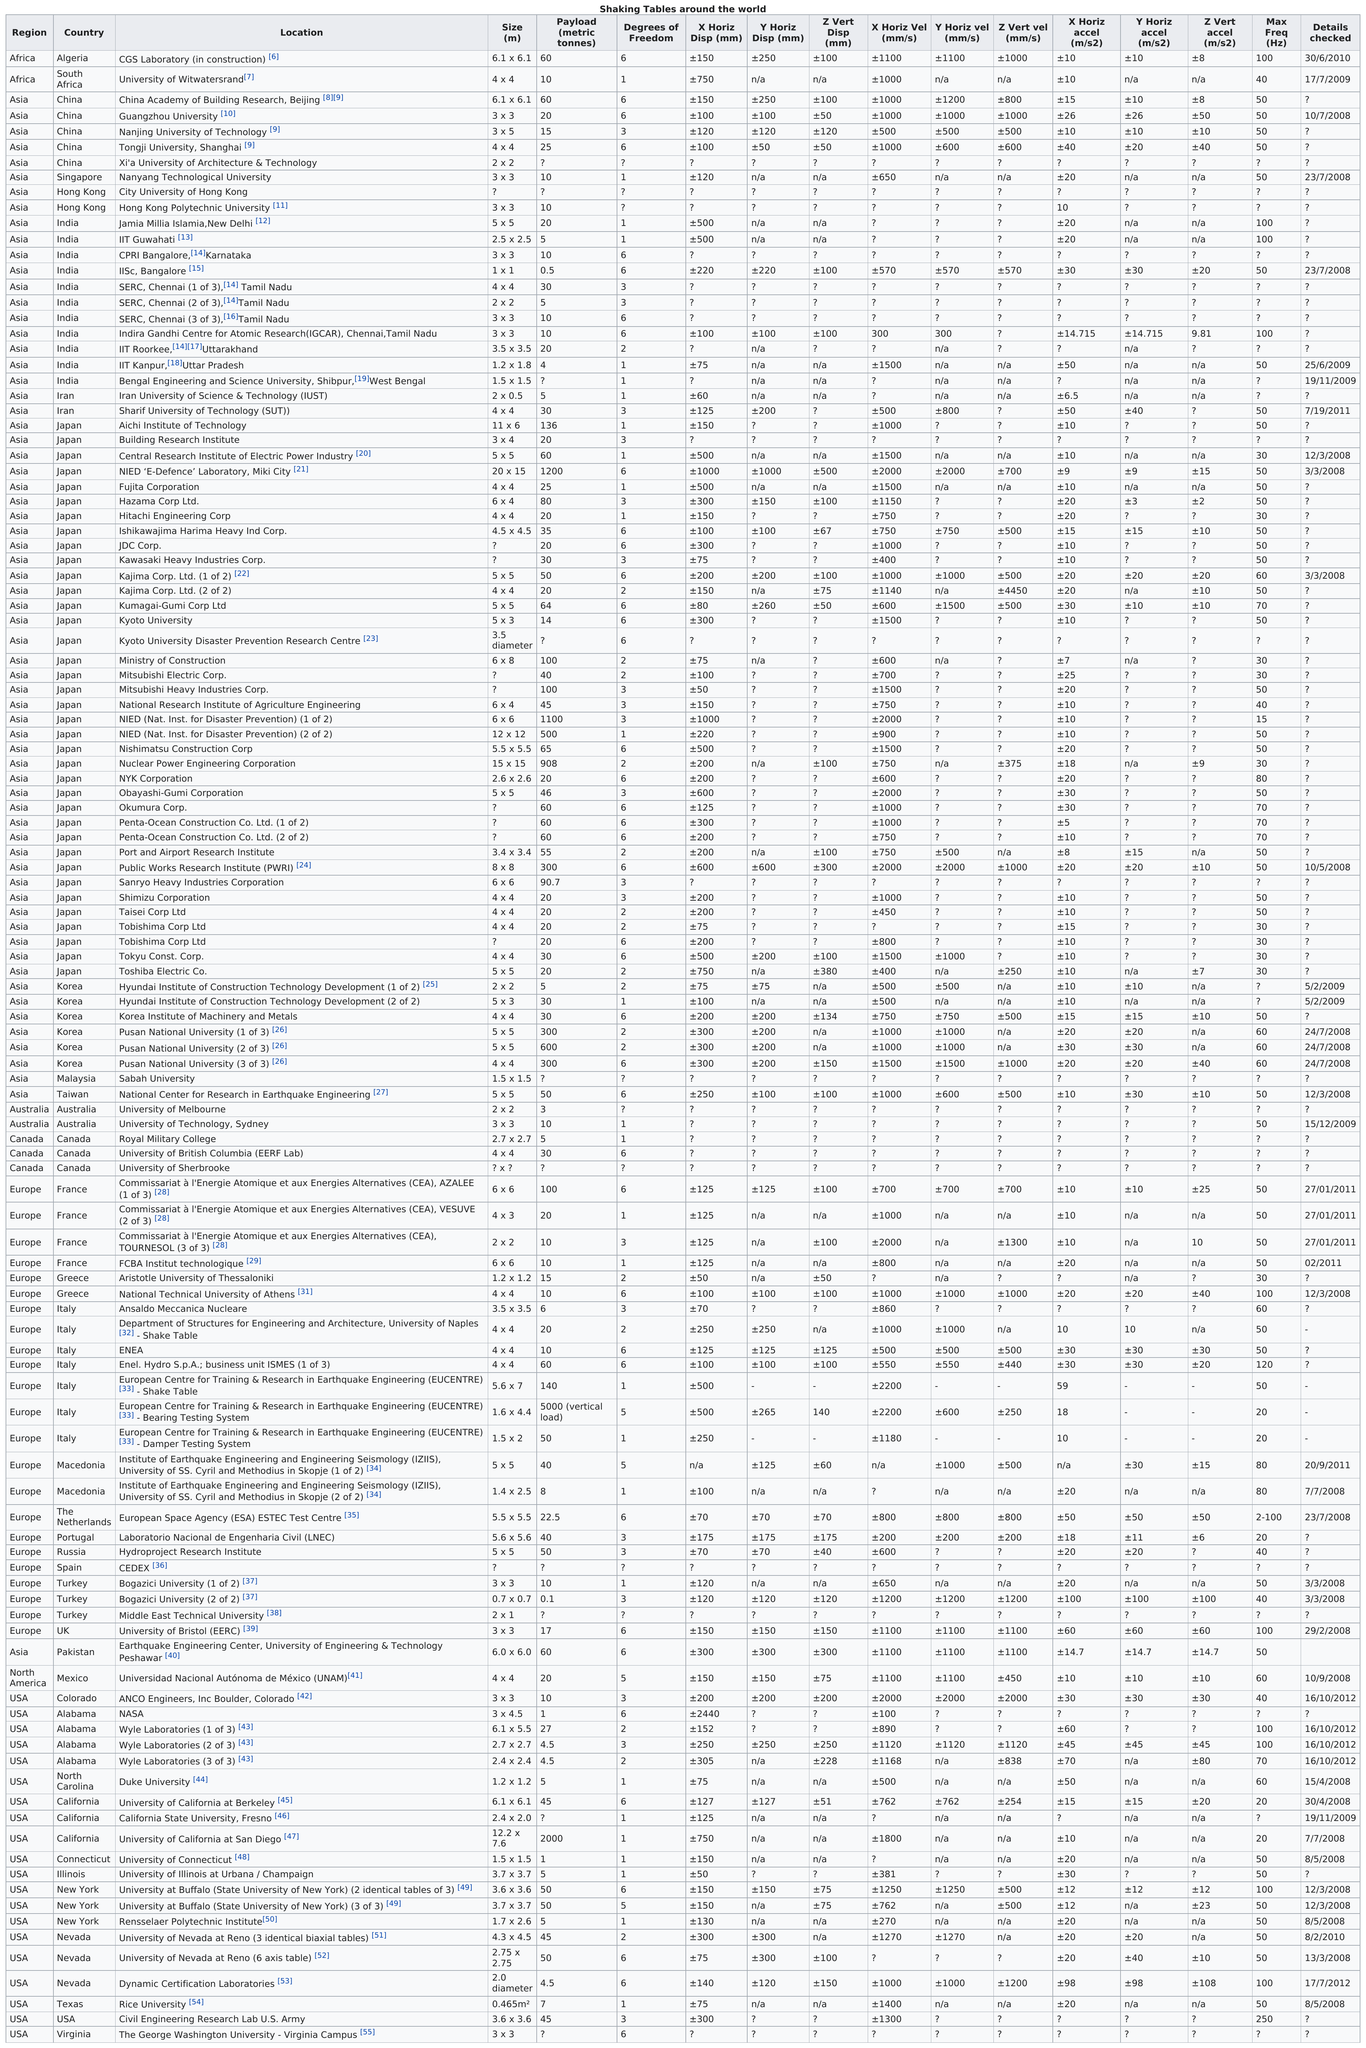Mention a couple of crucial points in this snapshot. Virginia, a country, is the last on the list. The University of Witwatersrand has a higher horizontal displacement than IIT Guwahati. The size of Algeria is approximately 6.1 meters. In the table, the field that comes before size is location. Algeria and South Africa are both located in the region of Africa. 